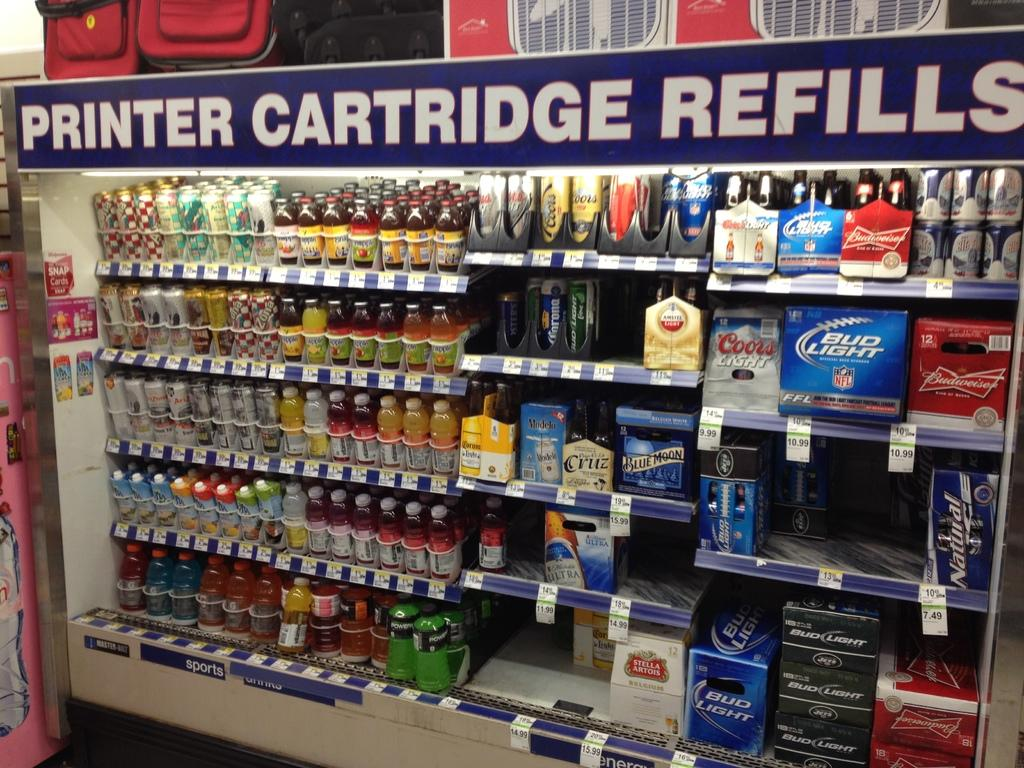<image>
Write a terse but informative summary of the picture. A store display of cartridge refills for printers. 